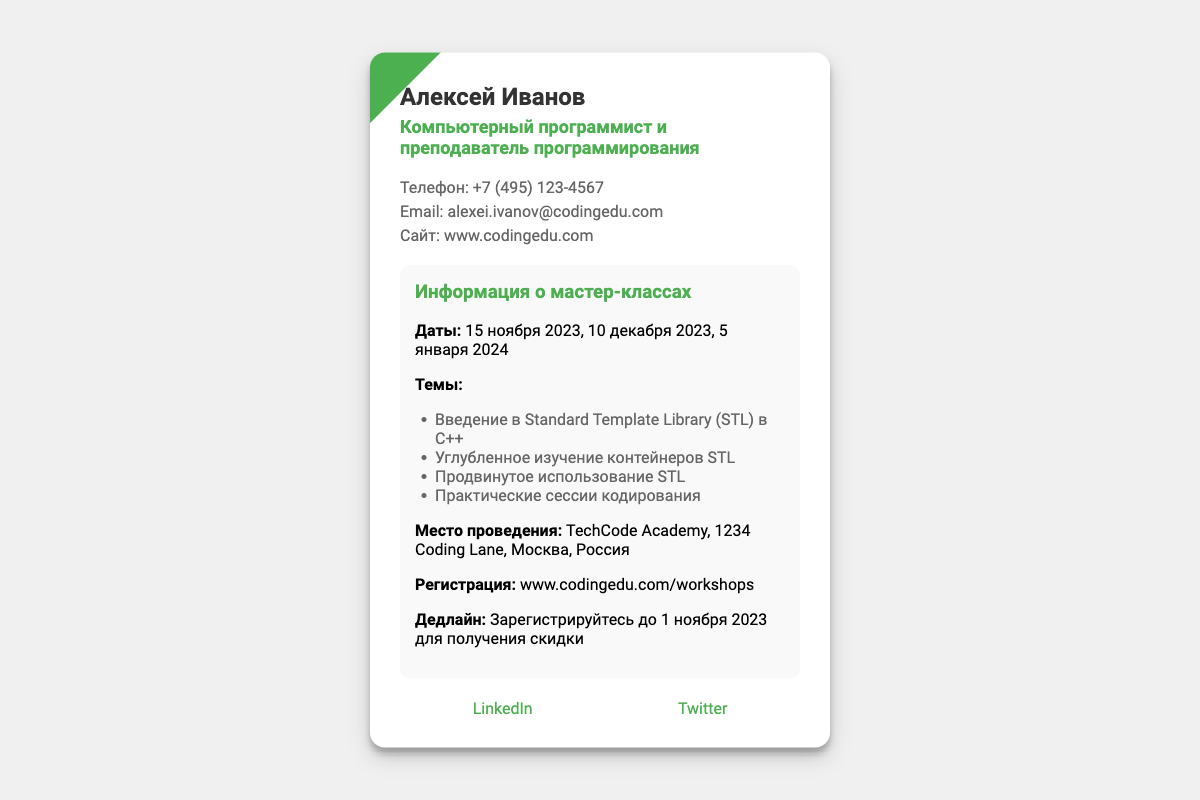Какое имя указано на визитной карточке? Имя на визитной карточке указано в заголовке.
Answer: Алексей Иванов Какой телефон указан на визитке? Номер телефона представлен в разделе контактной информации.
Answer: +7 (495) 123-4567 Когда будет проходить первый мастер-класс? Дата первого мастер-класса упоминается в информации о мастер-классах.
Answer: 15 ноября 2023 Какое место проведения мастер-классов? Место проведения указано в разделе информации о мастер-классах.
Answer: TechCode Academy, 1234 Coding Lane, Москва, Россия Сколько тем будет охвачено на мастер-классах? Количество тем можно узнать по списку, указанному в разделе информации о мастер-классах.
Answer: 4 тем Какой дедлайн для регистрации на мастер-классы? Дедлайн для регистрации указан в разделе информации о мастер-классах.
Answer: 1 ноября 2023 Где можно зарегистрироваться на мастер-классы? Ссылка для регистрации указана в разделе информации о мастер-классах.
Answer: www.codingedu.com/workshops Какие темы будут охвачены на мастер-классах? Темы мастер-классов перечислены в виде списка.
Answer: Введение в Standard Template Library (STL) в C++, Углубленное изучение контейнеров STL, Продвинутое использование STL, Практические сессии кодирования Кто проводит мастер-классы? Название лица, проводящего мастер-классы, указано в заголовке визитной карточки.
Answer: Алексей Иванов 